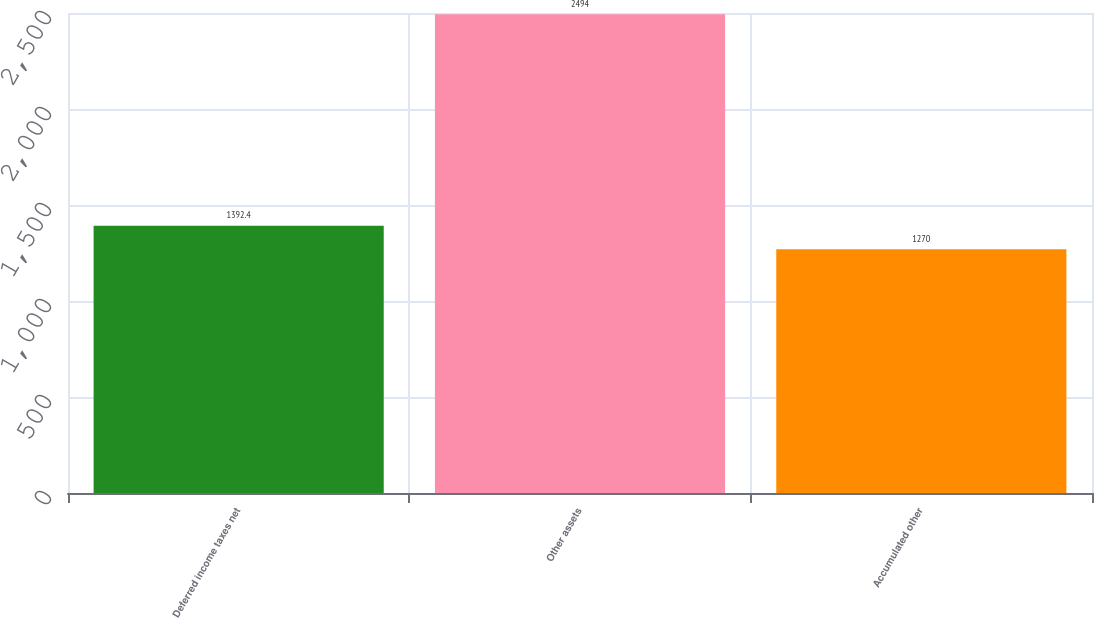Convert chart to OTSL. <chart><loc_0><loc_0><loc_500><loc_500><bar_chart><fcel>Deferred income taxes net<fcel>Other assets<fcel>Accumulated other<nl><fcel>1392.4<fcel>2494<fcel>1270<nl></chart> 